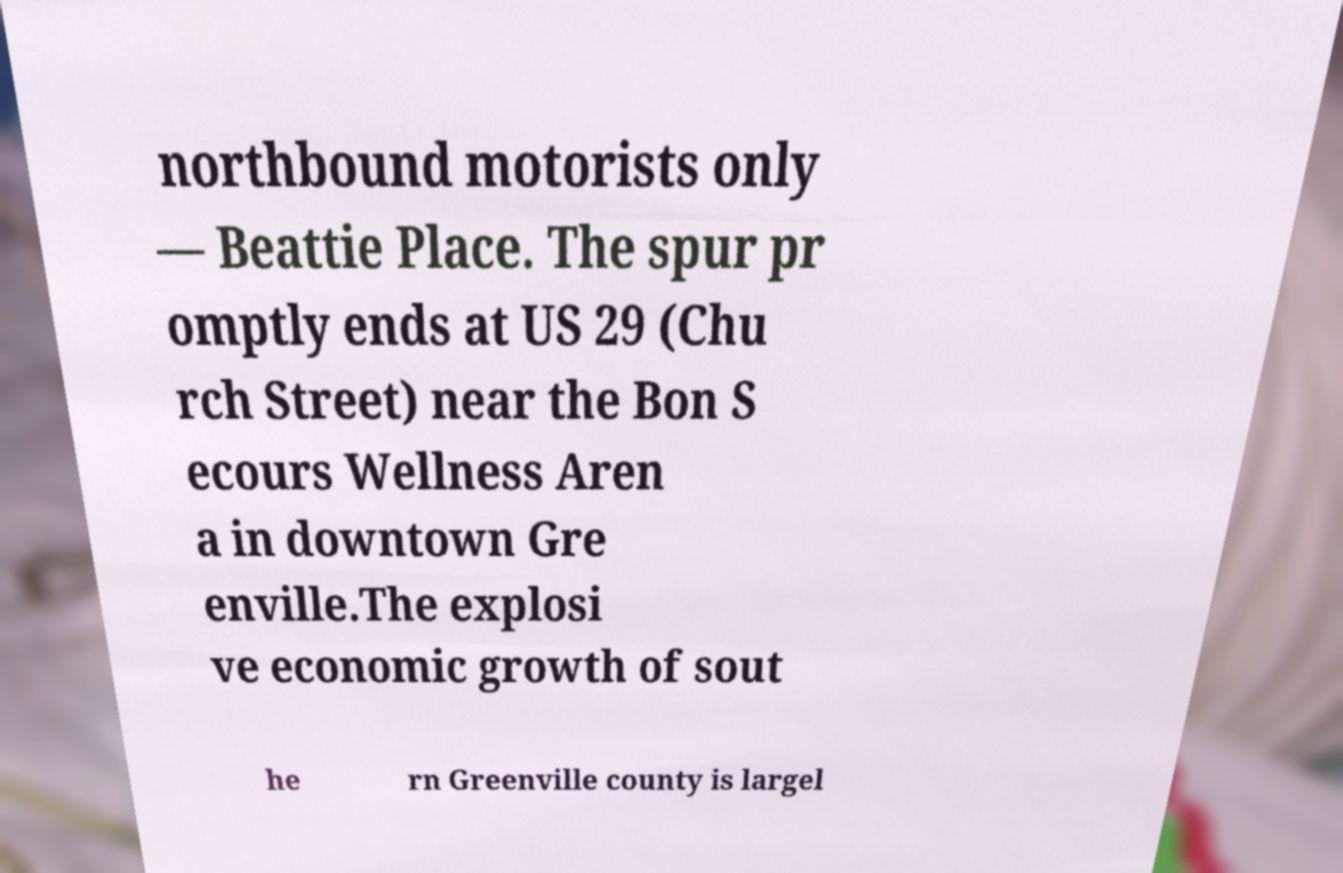Could you extract and type out the text from this image? northbound motorists only — Beattie Place. The spur pr omptly ends at US 29 (Chu rch Street) near the Bon S ecours Wellness Aren a in downtown Gre enville.The explosi ve economic growth of sout he rn Greenville county is largel 